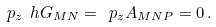<formula> <loc_0><loc_0><loc_500><loc_500>\ p _ { z } \ h G _ { M N } = \ p _ { z } A _ { M N P } = 0 \, .</formula> 